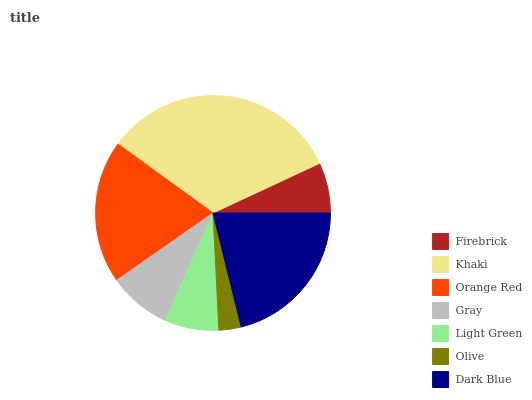Is Olive the minimum?
Answer yes or no. Yes. Is Khaki the maximum?
Answer yes or no. Yes. Is Orange Red the minimum?
Answer yes or no. No. Is Orange Red the maximum?
Answer yes or no. No. Is Khaki greater than Orange Red?
Answer yes or no. Yes. Is Orange Red less than Khaki?
Answer yes or no. Yes. Is Orange Red greater than Khaki?
Answer yes or no. No. Is Khaki less than Orange Red?
Answer yes or no. No. Is Gray the high median?
Answer yes or no. Yes. Is Gray the low median?
Answer yes or no. Yes. Is Light Green the high median?
Answer yes or no. No. Is Orange Red the low median?
Answer yes or no. No. 